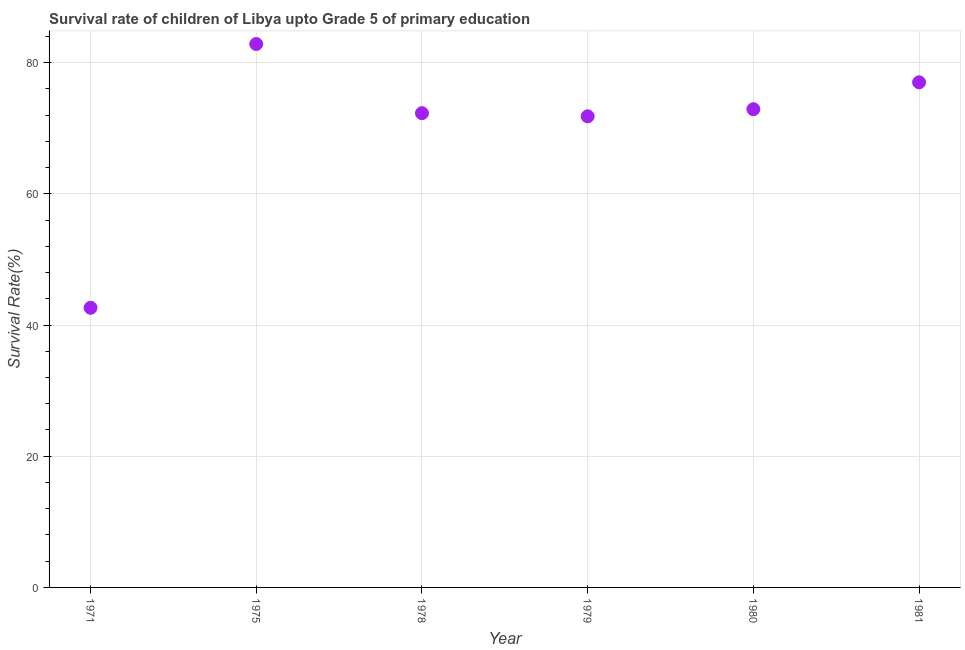What is the survival rate in 1971?
Your answer should be compact. 42.63. Across all years, what is the maximum survival rate?
Provide a short and direct response. 82.84. Across all years, what is the minimum survival rate?
Ensure brevity in your answer.  42.63. In which year was the survival rate maximum?
Provide a short and direct response. 1975. In which year was the survival rate minimum?
Offer a terse response. 1971. What is the sum of the survival rate?
Offer a very short reply. 419.51. What is the difference between the survival rate in 1979 and 1981?
Ensure brevity in your answer.  -5.18. What is the average survival rate per year?
Provide a short and direct response. 69.92. What is the median survival rate?
Keep it short and to the point. 72.6. In how many years, is the survival rate greater than 44 %?
Provide a succinct answer. 5. Do a majority of the years between 1975 and 1979 (inclusive) have survival rate greater than 8 %?
Provide a short and direct response. Yes. What is the ratio of the survival rate in 1975 to that in 1979?
Offer a very short reply. 1.15. Is the survival rate in 1971 less than that in 1975?
Offer a very short reply. Yes. What is the difference between the highest and the second highest survival rate?
Your response must be concise. 5.84. Is the sum of the survival rate in 1971 and 1975 greater than the maximum survival rate across all years?
Ensure brevity in your answer.  Yes. What is the difference between the highest and the lowest survival rate?
Offer a terse response. 40.21. Does the survival rate monotonically increase over the years?
Your response must be concise. No. How many years are there in the graph?
Make the answer very short. 6. What is the title of the graph?
Your answer should be compact. Survival rate of children of Libya upto Grade 5 of primary education. What is the label or title of the Y-axis?
Provide a short and direct response. Survival Rate(%). What is the Survival Rate(%) in 1971?
Keep it short and to the point. 42.63. What is the Survival Rate(%) in 1975?
Your response must be concise. 82.84. What is the Survival Rate(%) in 1978?
Give a very brief answer. 72.3. What is the Survival Rate(%) in 1979?
Provide a short and direct response. 71.82. What is the Survival Rate(%) in 1980?
Provide a short and direct response. 72.91. What is the Survival Rate(%) in 1981?
Keep it short and to the point. 77. What is the difference between the Survival Rate(%) in 1971 and 1975?
Give a very brief answer. -40.21. What is the difference between the Survival Rate(%) in 1971 and 1978?
Give a very brief answer. -29.67. What is the difference between the Survival Rate(%) in 1971 and 1979?
Make the answer very short. -29.19. What is the difference between the Survival Rate(%) in 1971 and 1980?
Ensure brevity in your answer.  -30.27. What is the difference between the Survival Rate(%) in 1971 and 1981?
Keep it short and to the point. -34.37. What is the difference between the Survival Rate(%) in 1975 and 1978?
Your response must be concise. 10.54. What is the difference between the Survival Rate(%) in 1975 and 1979?
Offer a very short reply. 11.02. What is the difference between the Survival Rate(%) in 1975 and 1980?
Make the answer very short. 9.94. What is the difference between the Survival Rate(%) in 1975 and 1981?
Keep it short and to the point. 5.84. What is the difference between the Survival Rate(%) in 1978 and 1979?
Ensure brevity in your answer.  0.48. What is the difference between the Survival Rate(%) in 1978 and 1980?
Provide a short and direct response. -0.61. What is the difference between the Survival Rate(%) in 1978 and 1981?
Your answer should be compact. -4.7. What is the difference between the Survival Rate(%) in 1979 and 1980?
Make the answer very short. -1.09. What is the difference between the Survival Rate(%) in 1979 and 1981?
Your answer should be very brief. -5.18. What is the difference between the Survival Rate(%) in 1980 and 1981?
Keep it short and to the point. -4.1. What is the ratio of the Survival Rate(%) in 1971 to that in 1975?
Your answer should be very brief. 0.52. What is the ratio of the Survival Rate(%) in 1971 to that in 1978?
Provide a short and direct response. 0.59. What is the ratio of the Survival Rate(%) in 1971 to that in 1979?
Keep it short and to the point. 0.59. What is the ratio of the Survival Rate(%) in 1971 to that in 1980?
Make the answer very short. 0.58. What is the ratio of the Survival Rate(%) in 1971 to that in 1981?
Keep it short and to the point. 0.55. What is the ratio of the Survival Rate(%) in 1975 to that in 1978?
Provide a short and direct response. 1.15. What is the ratio of the Survival Rate(%) in 1975 to that in 1979?
Ensure brevity in your answer.  1.15. What is the ratio of the Survival Rate(%) in 1975 to that in 1980?
Ensure brevity in your answer.  1.14. What is the ratio of the Survival Rate(%) in 1975 to that in 1981?
Offer a very short reply. 1.08. What is the ratio of the Survival Rate(%) in 1978 to that in 1980?
Your answer should be very brief. 0.99. What is the ratio of the Survival Rate(%) in 1978 to that in 1981?
Give a very brief answer. 0.94. What is the ratio of the Survival Rate(%) in 1979 to that in 1981?
Offer a terse response. 0.93. What is the ratio of the Survival Rate(%) in 1980 to that in 1981?
Your response must be concise. 0.95. 